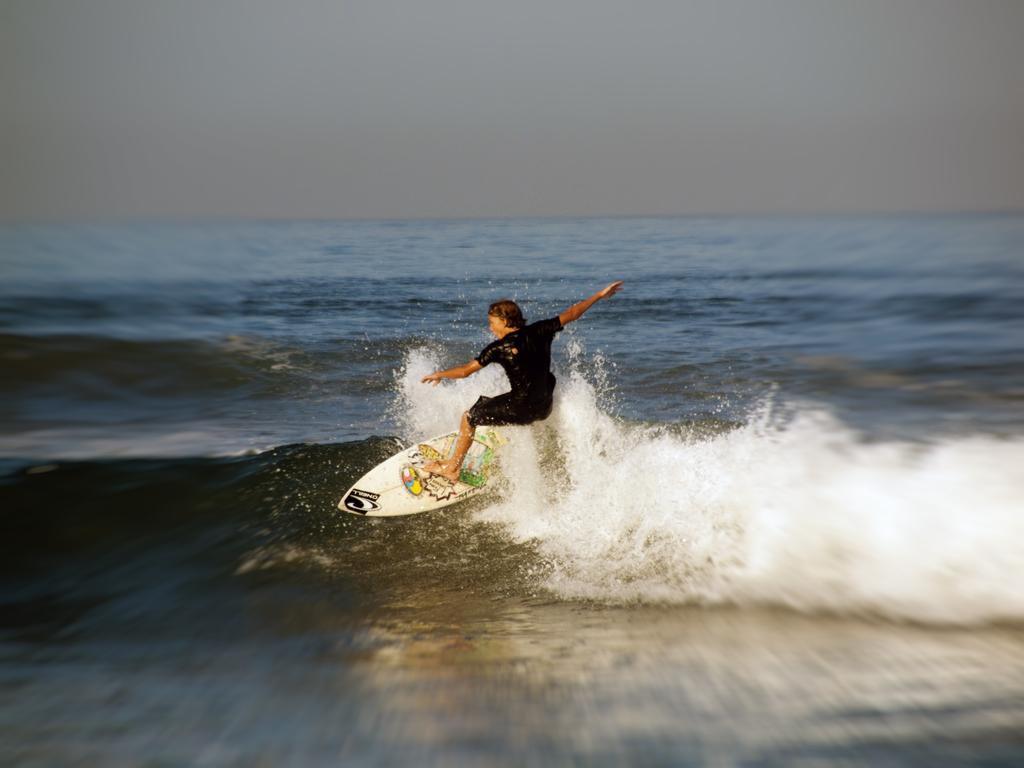Describe this image in one or two sentences. In this image, we can see a person surfing with a surfboard on the water. There is the sky at the top of the image. 